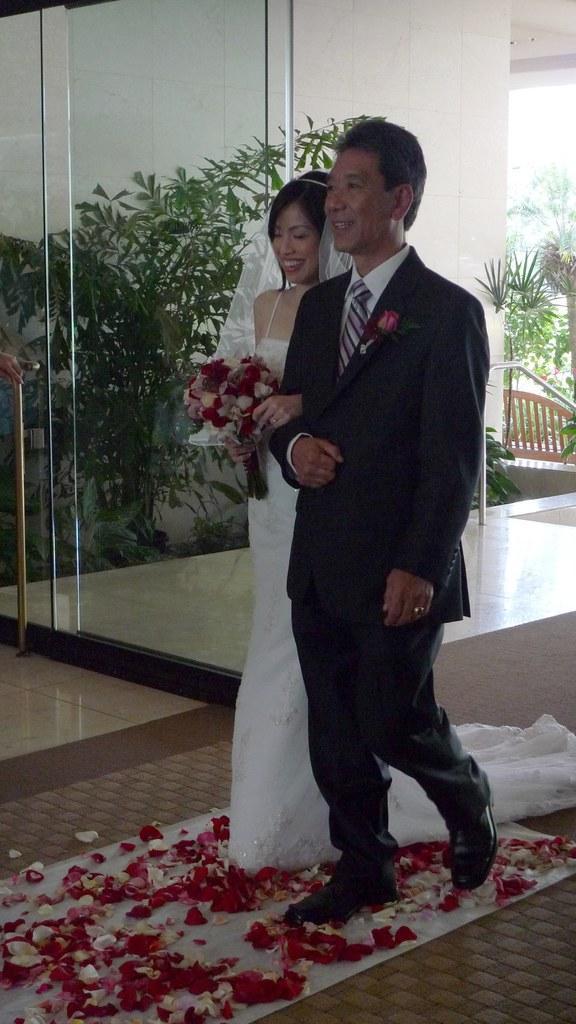In one or two sentences, can you explain what this image depicts? In this image there is a couple who are walking on the carpet. On the carpet there are flowers. In the background there is a glass door through which we can see there is a plant. The woman looks like a bride who is carrying the flowers. 